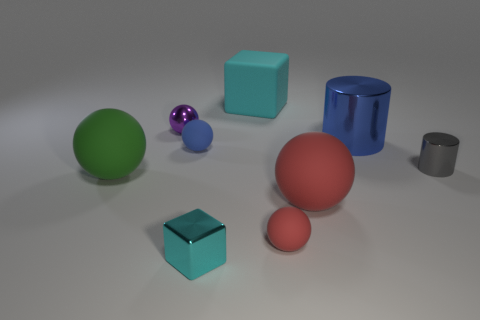Subtract all purple spheres. How many spheres are left? 4 Subtract all big green rubber balls. How many balls are left? 4 Add 1 big red rubber spheres. How many objects exist? 10 Subtract all brown balls. Subtract all yellow blocks. How many balls are left? 5 Subtract all spheres. How many objects are left? 4 Add 4 red rubber things. How many red rubber things are left? 6 Add 4 red matte spheres. How many red matte spheres exist? 6 Subtract 0 brown cubes. How many objects are left? 9 Subtract all red rubber balls. Subtract all purple objects. How many objects are left? 6 